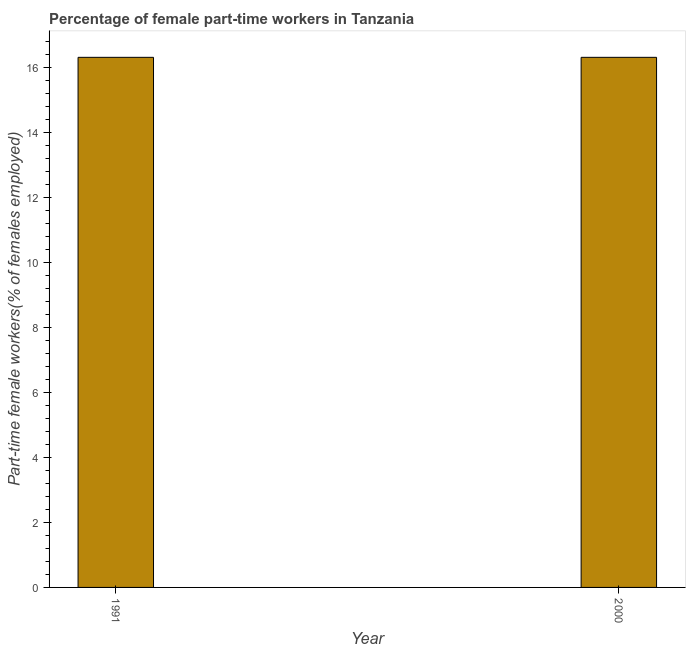Does the graph contain any zero values?
Keep it short and to the point. No. Does the graph contain grids?
Ensure brevity in your answer.  No. What is the title of the graph?
Keep it short and to the point. Percentage of female part-time workers in Tanzania. What is the label or title of the Y-axis?
Provide a short and direct response. Part-time female workers(% of females employed). What is the percentage of part-time female workers in 1991?
Provide a succinct answer. 16.3. Across all years, what is the maximum percentage of part-time female workers?
Provide a succinct answer. 16.3. Across all years, what is the minimum percentage of part-time female workers?
Your answer should be compact. 16.3. What is the sum of the percentage of part-time female workers?
Provide a succinct answer. 32.6. What is the average percentage of part-time female workers per year?
Offer a very short reply. 16.3. What is the median percentage of part-time female workers?
Offer a very short reply. 16.3. Do a majority of the years between 1991 and 2000 (inclusive) have percentage of part-time female workers greater than 9.6 %?
Your answer should be very brief. Yes. What is the ratio of the percentage of part-time female workers in 1991 to that in 2000?
Keep it short and to the point. 1. Is the percentage of part-time female workers in 1991 less than that in 2000?
Offer a terse response. No. Are all the bars in the graph horizontal?
Make the answer very short. No. Are the values on the major ticks of Y-axis written in scientific E-notation?
Your answer should be very brief. No. What is the Part-time female workers(% of females employed) of 1991?
Keep it short and to the point. 16.3. What is the Part-time female workers(% of females employed) in 2000?
Offer a terse response. 16.3. What is the difference between the Part-time female workers(% of females employed) in 1991 and 2000?
Give a very brief answer. 0. 